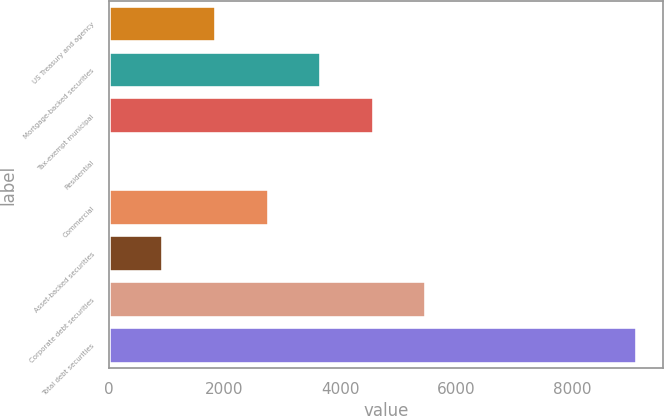Convert chart. <chart><loc_0><loc_0><loc_500><loc_500><bar_chart><fcel>US Treasury and agency<fcel>Mortgage-backed securities<fcel>Tax-exempt municipal<fcel>Residential<fcel>Commercial<fcel>Asset-backed securities<fcel>Corporate debt securities<fcel>Total debt securities<nl><fcel>1850.2<fcel>3667.4<fcel>4576<fcel>33<fcel>2758.8<fcel>941.6<fcel>5484.6<fcel>9119<nl></chart> 